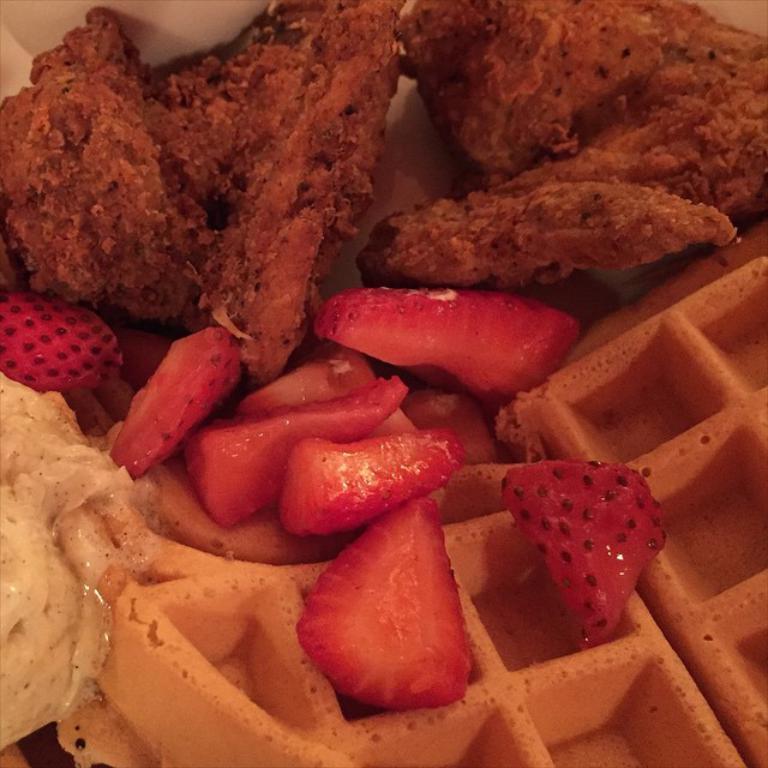In one or two sentences, can you explain what this image depicts? In this image, I can see the waffles, strawberry slices and some other food items. 